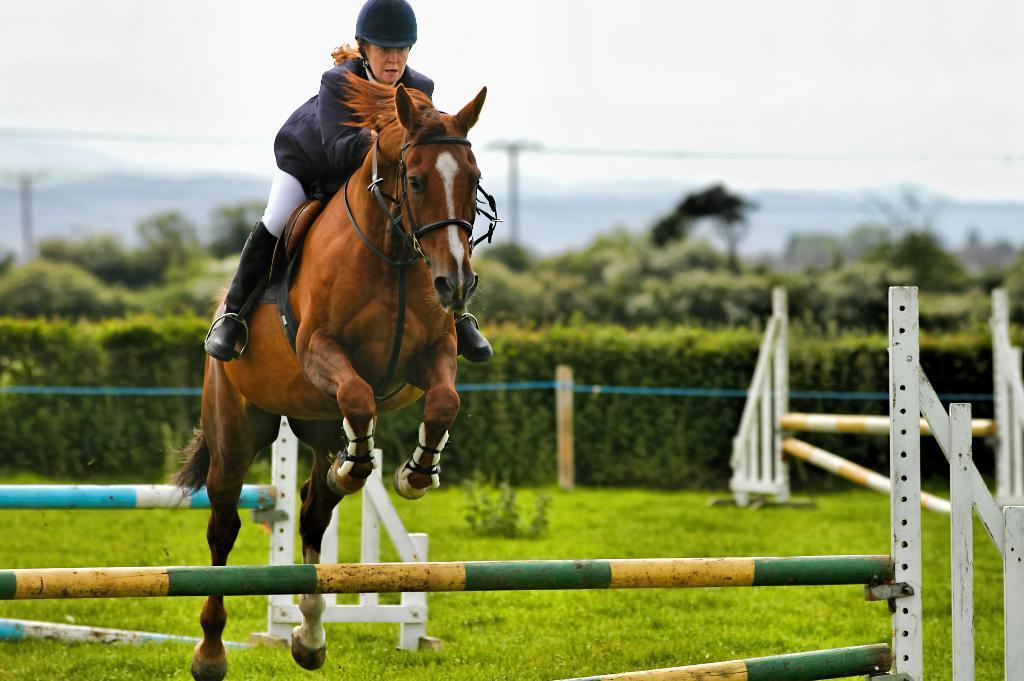In one or two sentences, can you explain what this image depicts? Here a woman is riding horse behind her there are plants and sky. 